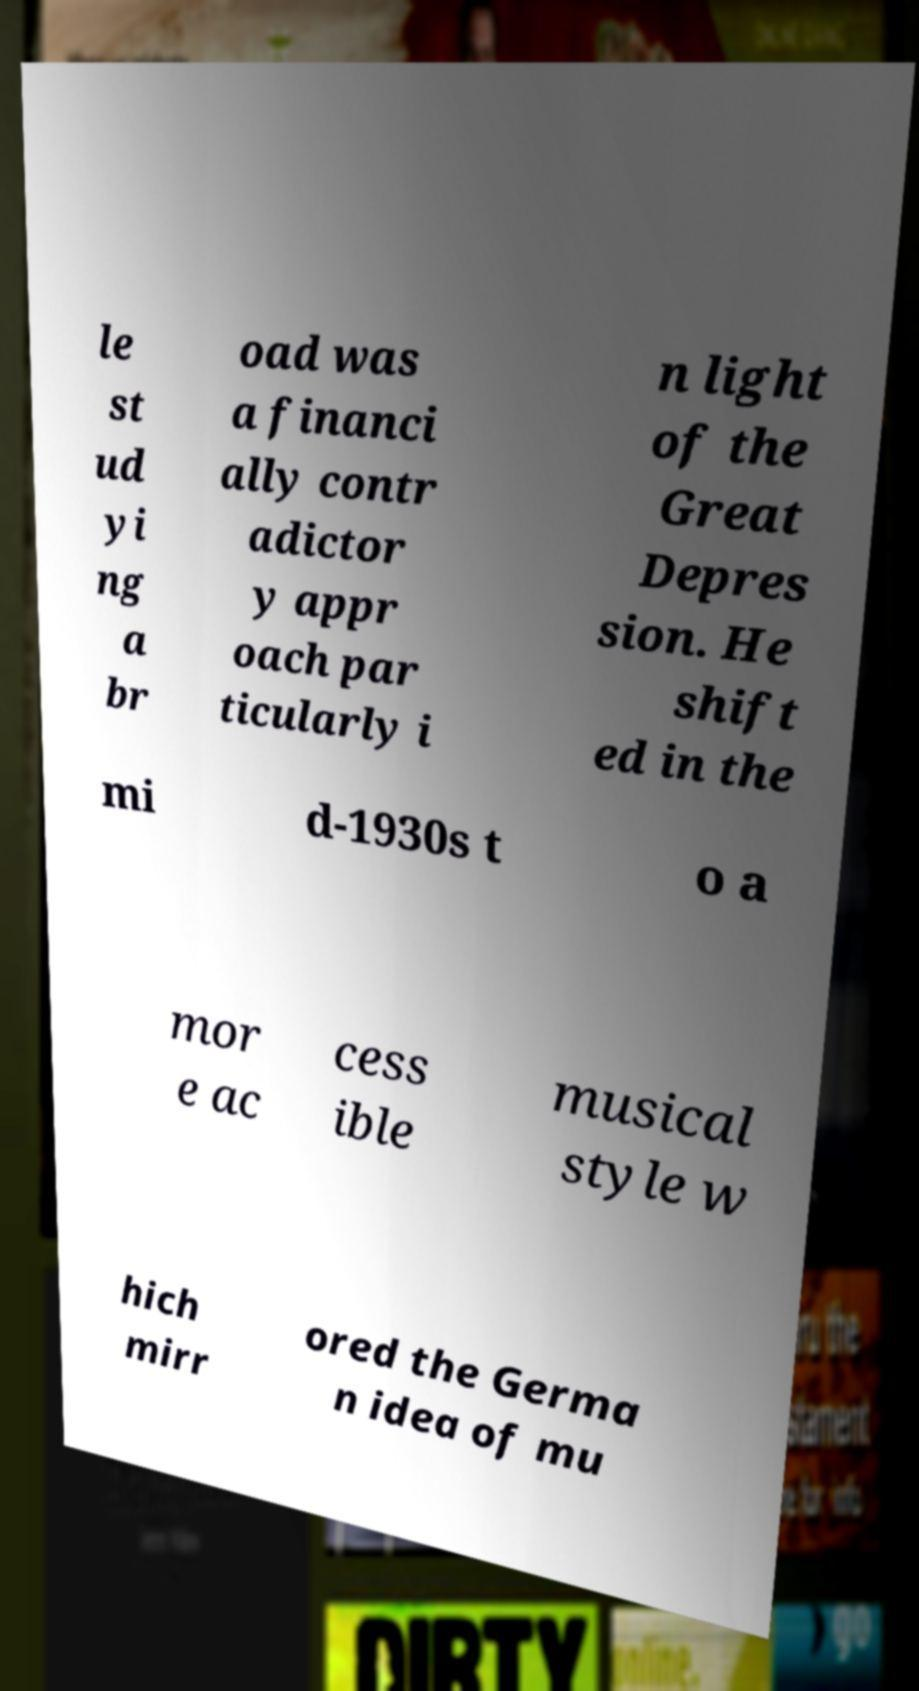Please read and relay the text visible in this image. What does it say? le st ud yi ng a br oad was a financi ally contr adictor y appr oach par ticularly i n light of the Great Depres sion. He shift ed in the mi d-1930s t o a mor e ac cess ible musical style w hich mirr ored the Germa n idea of mu 